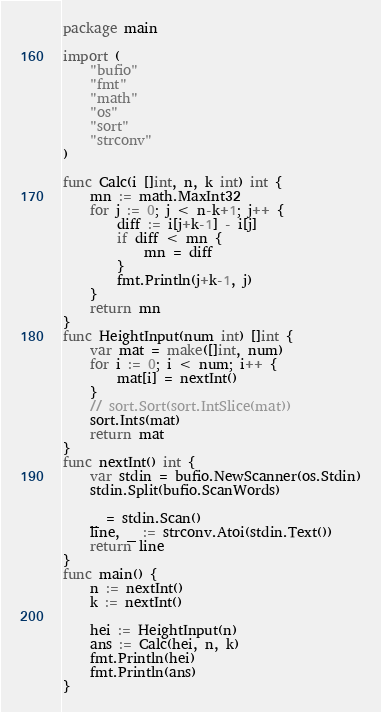<code> <loc_0><loc_0><loc_500><loc_500><_Go_>package main

import (
	"bufio"
	"fmt"
	"math"
	"os"
	"sort"
	"strconv"
)

func Calc(i []int, n, k int) int {
	mn := math.MaxInt32
	for j := 0; j < n-k+1; j++ {
		diff := i[j+k-1] - i[j]
		if diff < mn {
			mn = diff
		}
		fmt.Println(j+k-1, j)
	}
	return mn
}
func HeightInput(num int) []int {
	var mat = make([]int, num)
	for i := 0; i < num; i++ {
		mat[i] = nextInt()
	}
	// sort.Sort(sort.IntSlice(mat))
	sort.Ints(mat)
	return mat
}
func nextInt() int {
	var stdin = bufio.NewScanner(os.Stdin)
	stdin.Split(bufio.ScanWords)

	_ = stdin.Scan()
	line, _ := strconv.Atoi(stdin.Text())
	return line
}
func main() {
	n := nextInt()
	k := nextInt()

	hei := HeightInput(n)
	ans := Calc(hei, n, k)
	fmt.Println(hei)
	fmt.Println(ans)
}
</code> 